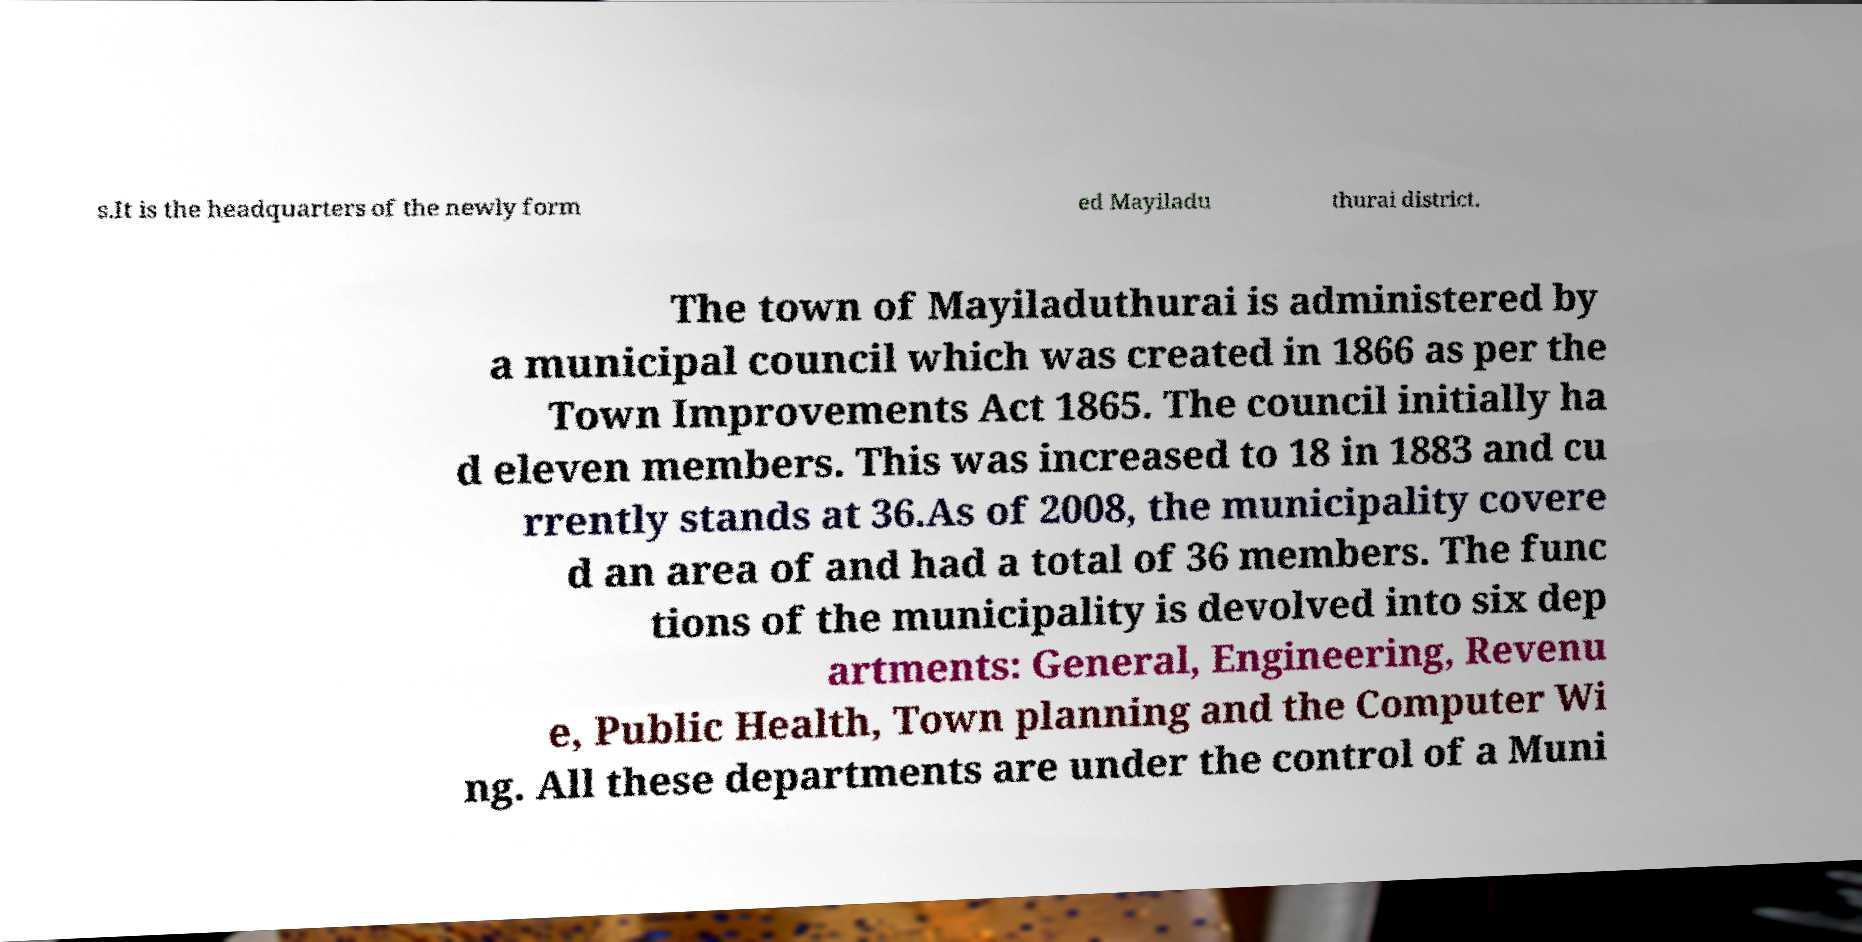Please identify and transcribe the text found in this image. s.It is the headquarters of the newly form ed Mayiladu thurai district. The town of Mayiladuthurai is administered by a municipal council which was created in 1866 as per the Town Improvements Act 1865. The council initially ha d eleven members. This was increased to 18 in 1883 and cu rrently stands at 36.As of 2008, the municipality covere d an area of and had a total of 36 members. The func tions of the municipality is devolved into six dep artments: General, Engineering, Revenu e, Public Health, Town planning and the Computer Wi ng. All these departments are under the control of a Muni 